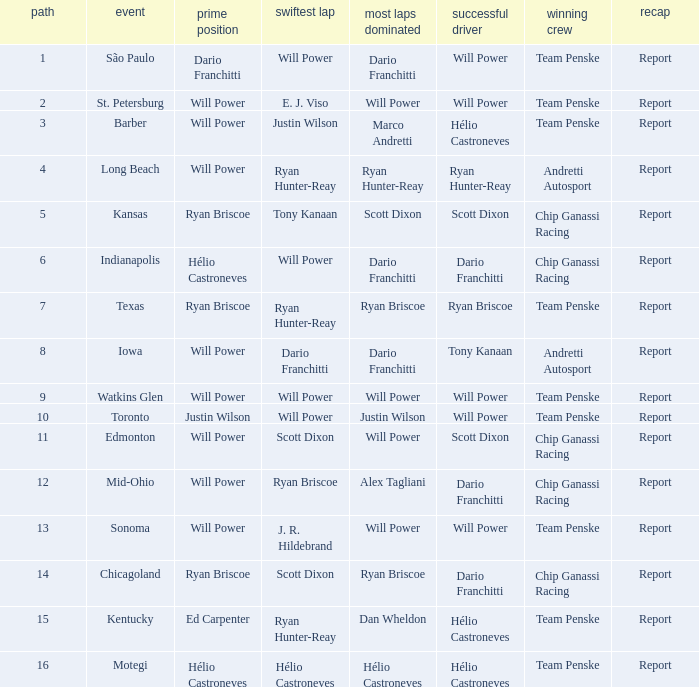Who was on the pole at Chicagoland? Ryan Briscoe. 